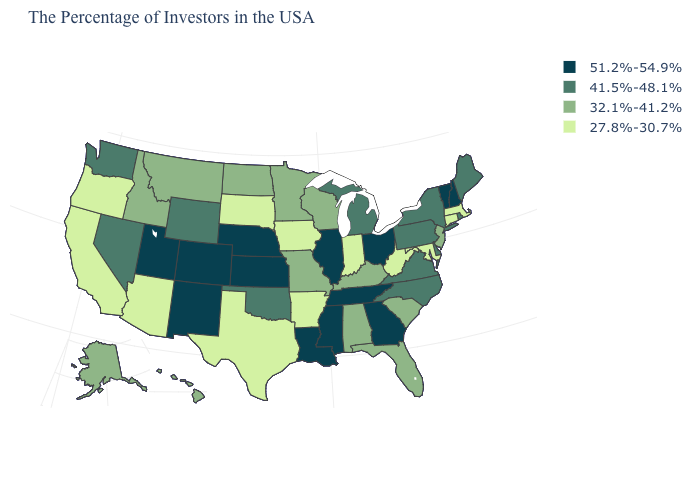What is the value of New York?
Answer briefly. 41.5%-48.1%. Is the legend a continuous bar?
Write a very short answer. No. Name the states that have a value in the range 32.1%-41.2%?
Give a very brief answer. New Jersey, South Carolina, Florida, Kentucky, Alabama, Wisconsin, Missouri, Minnesota, North Dakota, Montana, Idaho, Alaska, Hawaii. Name the states that have a value in the range 51.2%-54.9%?
Concise answer only. New Hampshire, Vermont, Ohio, Georgia, Tennessee, Illinois, Mississippi, Louisiana, Kansas, Nebraska, Colorado, New Mexico, Utah. What is the lowest value in the USA?
Give a very brief answer. 27.8%-30.7%. Name the states that have a value in the range 27.8%-30.7%?
Quick response, please. Massachusetts, Connecticut, Maryland, West Virginia, Indiana, Arkansas, Iowa, Texas, South Dakota, Arizona, California, Oregon. Does Virginia have a higher value than Hawaii?
Give a very brief answer. Yes. Does the map have missing data?
Write a very short answer. No. Does the map have missing data?
Be succinct. No. Among the states that border Montana , which have the lowest value?
Short answer required. South Dakota. Name the states that have a value in the range 41.5%-48.1%?
Quick response, please. Maine, Rhode Island, New York, Delaware, Pennsylvania, Virginia, North Carolina, Michigan, Oklahoma, Wyoming, Nevada, Washington. Name the states that have a value in the range 27.8%-30.7%?
Concise answer only. Massachusetts, Connecticut, Maryland, West Virginia, Indiana, Arkansas, Iowa, Texas, South Dakota, Arizona, California, Oregon. What is the value of Arkansas?
Short answer required. 27.8%-30.7%. What is the value of New Mexico?
Be succinct. 51.2%-54.9%. 